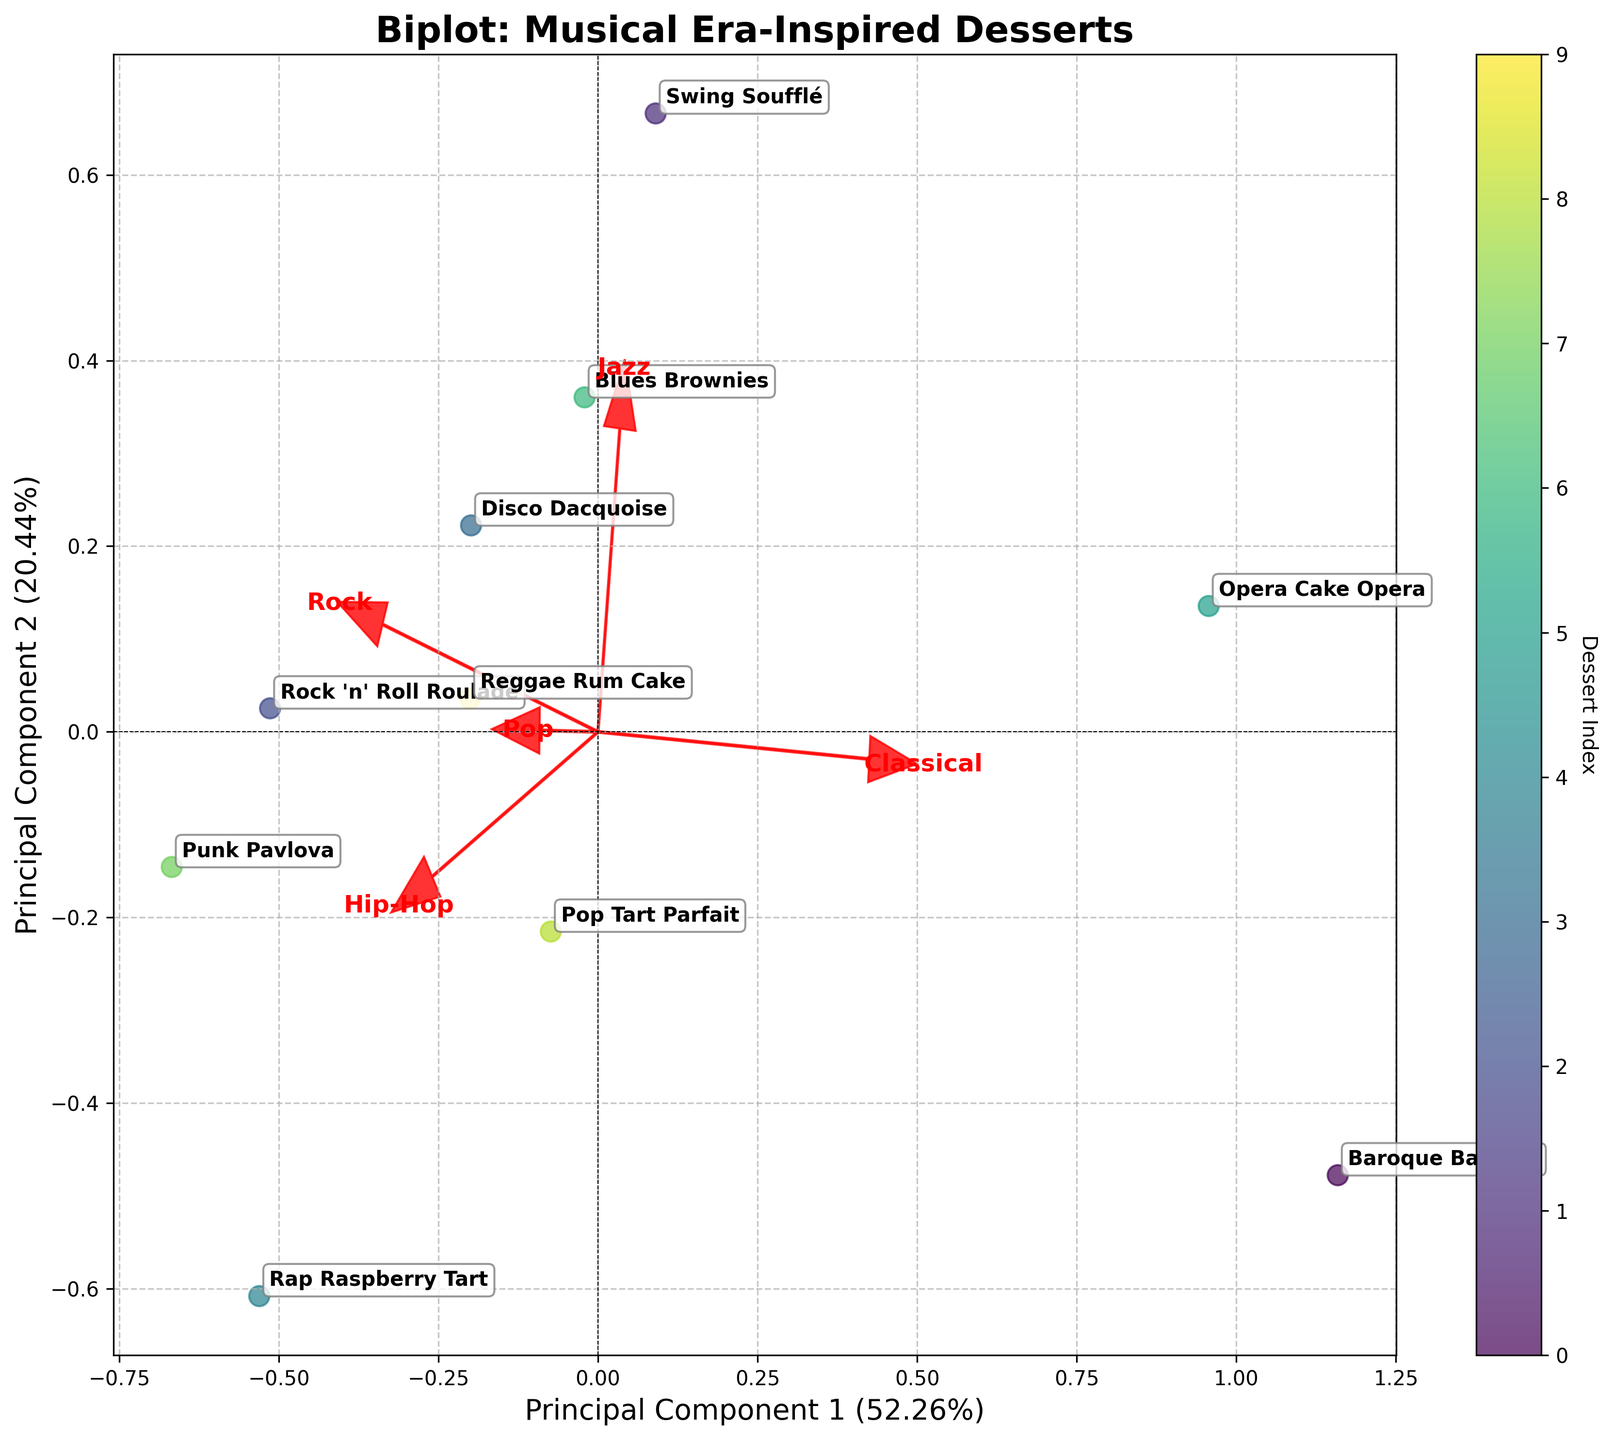What is the title of the figure? The title is typically displayed at the top of the figure and sets the context for what the plot is about.
Answer: Biplot: Musical Era-Inspired Desserts Which dessert has the highest value along Principal Component 1 (PC1)? To find the dessert with the highest value along PC1, look for the point farthest to the right on the x-axis.
Answer: Baroque Baklava How many desserts are plotted in the figure? Count each annotated dessert in the plot to determine the total number of data points.
Answer: 10 Which musical era is associated with a positive loading along both Principal Component 1 (PC1) and Component 2 (PC2)? Look at the directions of the loading vectors and find the one pointing to the first quadrant which has positive values on both PC1 and PC2.
Answer: Jazz What is the position of Swing Soufflé along Principal Component 1 (PC1)? Locate the label for Swing Soufflé and observe its x-axis value.
Answer: Negative (left of the origin) Which musical era-inspired dessert appears closest to the origin (0,0)? Identify the data point nearest to the intersection of the x-axis and y-axis.
Answer: Reggae Rum Cake Which musical era has the longest loading vector in the plot? Compare the lengths of the loading vectors to see which extends the farthest from the origin.
Answer: Classical Which two desserts are closest to each other on the plot? Measure the distance between points and identify the pair with the smallest distance between them.
Answer: Rock 'n' Roll Roulade and Punk Pavlova What is the direction of the loading vector for Hip-Hop? Observe the arrow labeled 'Hip-Hop' to determine its direction with respect to the x and y axes.
Answer: Mostly positive along PC2 Which dessert is most positively associated with Hip-Hop based on the loading vectors? Look at the orientation of the dessert points relative to the Hip-Hop loading vector.
Answer: Rap Raspberry Tart 